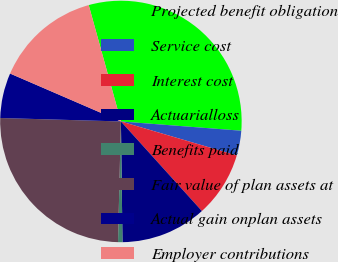Convert chart to OTSL. <chart><loc_0><loc_0><loc_500><loc_500><pie_chart><fcel>Projected benefit obligation<fcel>Service cost<fcel>Interest cost<fcel>Actuarialloss<fcel>Benefits paid<fcel>Fair value of plan assets at<fcel>Actual gain onplan assets<fcel>Employer contributions<nl><fcel>30.52%<fcel>3.32%<fcel>8.76%<fcel>11.49%<fcel>0.59%<fcel>25.07%<fcel>6.04%<fcel>14.21%<nl></chart> 